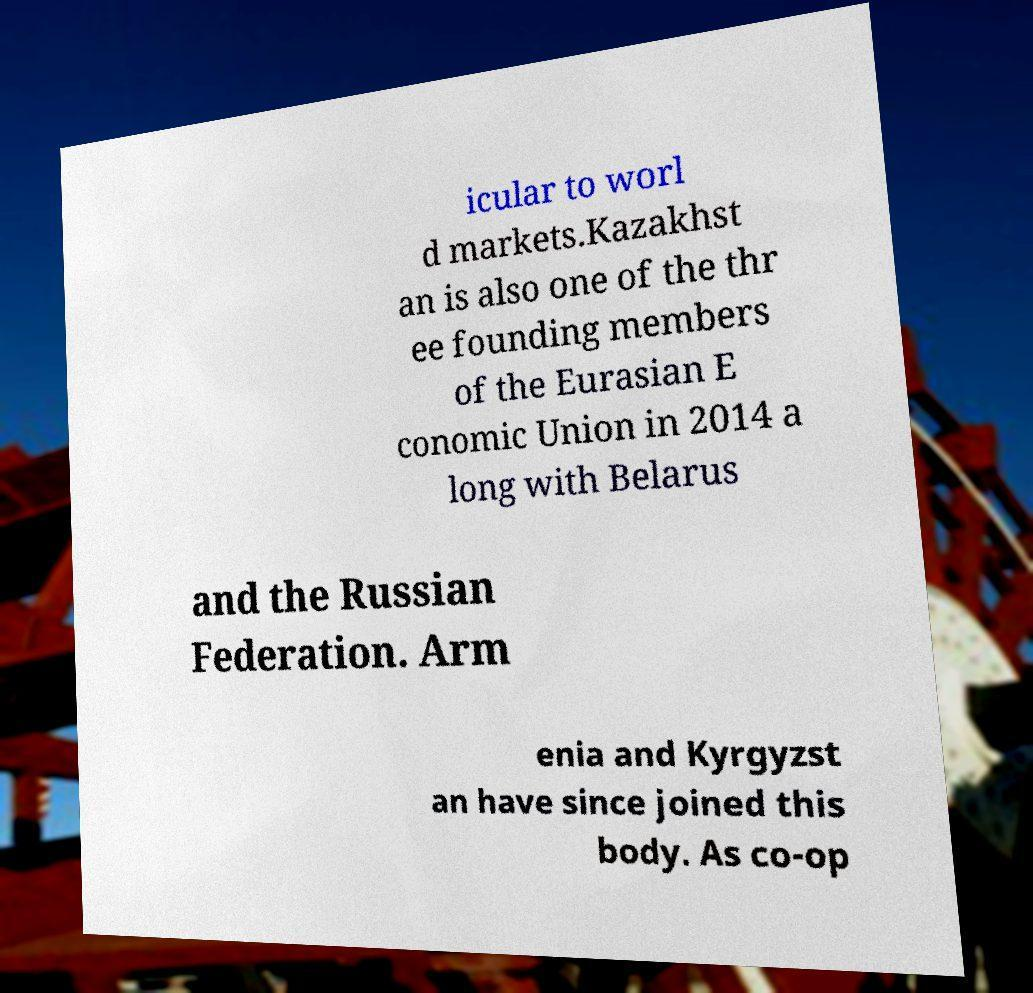I need the written content from this picture converted into text. Can you do that? icular to worl d markets.Kazakhst an is also one of the thr ee founding members of the Eurasian E conomic Union in 2014 a long with Belarus and the Russian Federation. Arm enia and Kyrgyzst an have since joined this body. As co-op 